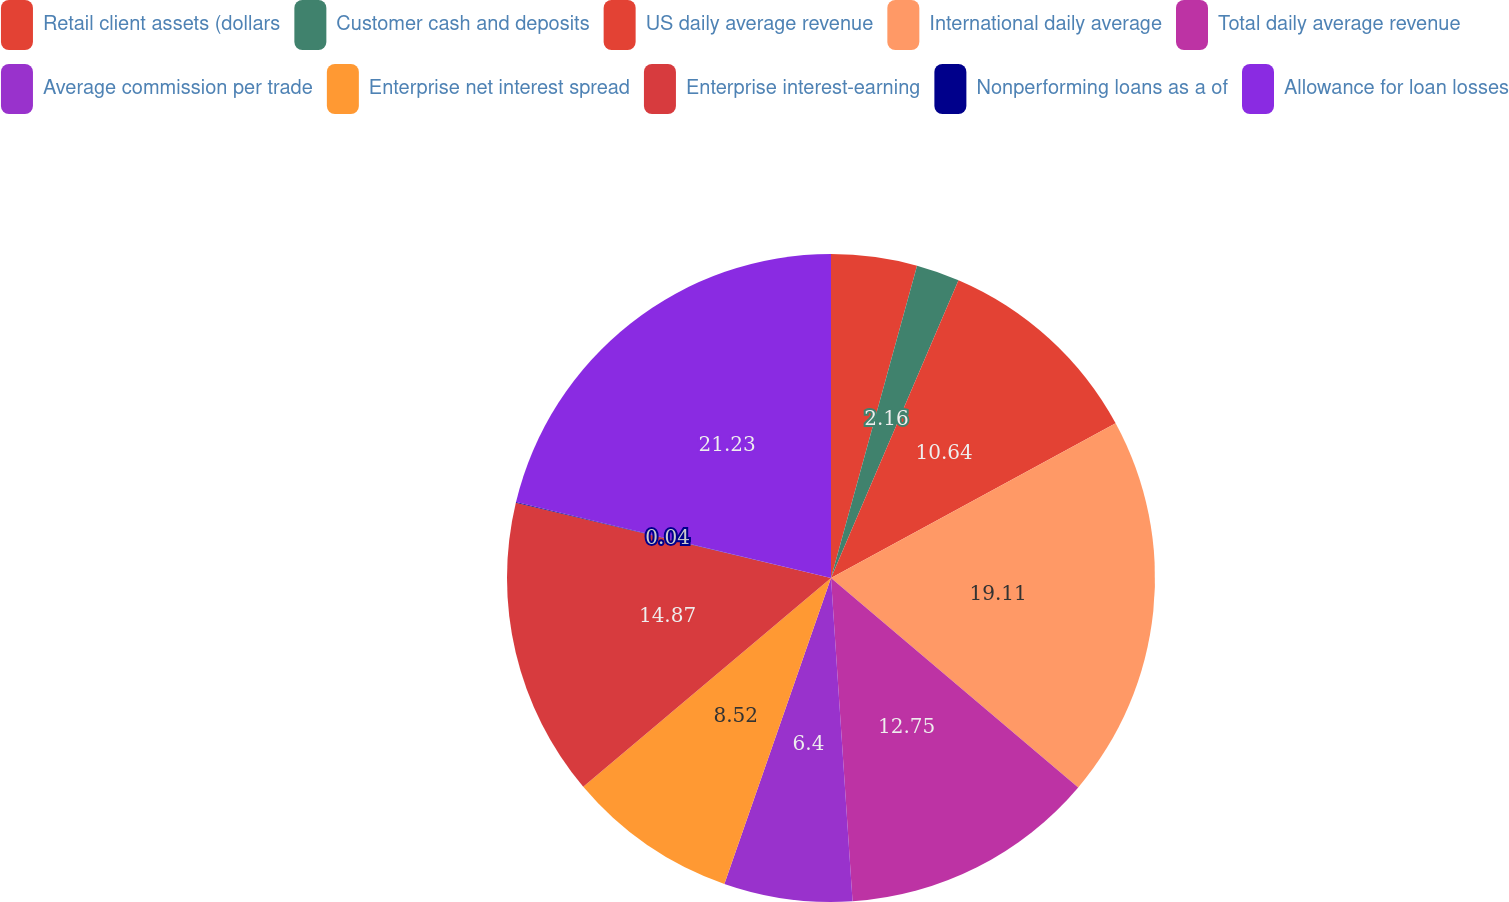<chart> <loc_0><loc_0><loc_500><loc_500><pie_chart><fcel>Retail client assets (dollars<fcel>Customer cash and deposits<fcel>US daily average revenue<fcel>International daily average<fcel>Total daily average revenue<fcel>Average commission per trade<fcel>Enterprise net interest spread<fcel>Enterprise interest-earning<fcel>Nonperforming loans as a of<fcel>Allowance for loan losses<nl><fcel>4.28%<fcel>2.16%<fcel>10.64%<fcel>19.12%<fcel>12.76%<fcel>6.4%<fcel>8.52%<fcel>14.88%<fcel>0.04%<fcel>21.24%<nl></chart> 